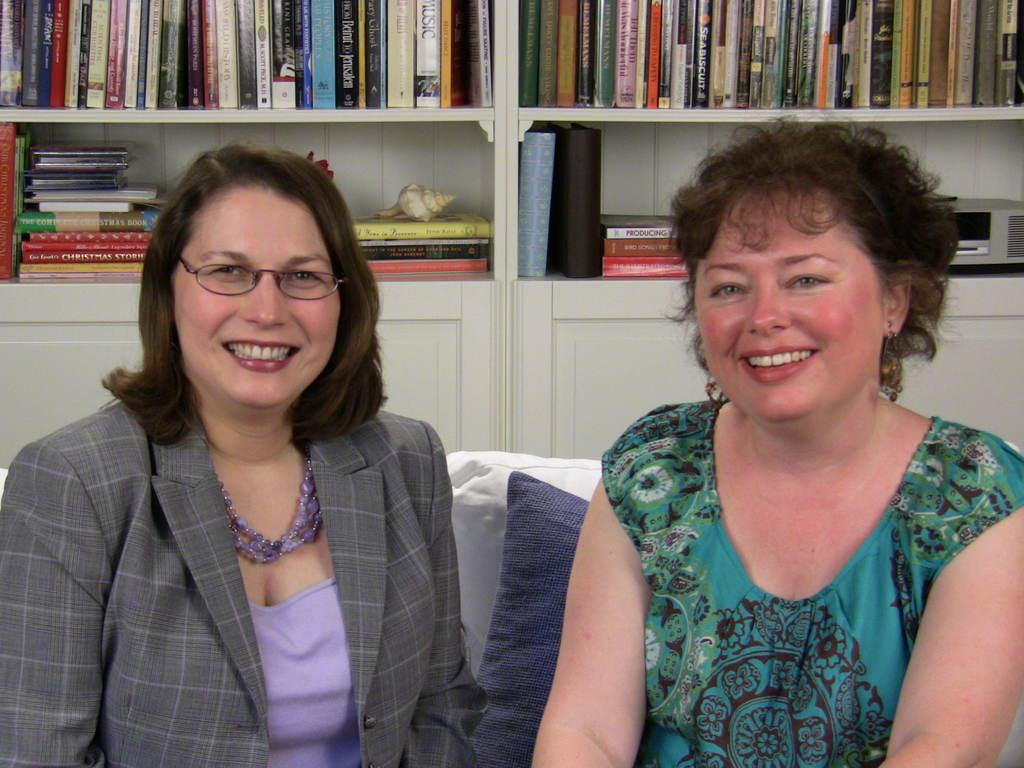How many women are sitting in the image? There are two women sitting in the image. What can be seen in the image that might provide comfort? Cushions are visible in the image. What is located on the backside of the image? There is a group of books, a device, and a shell placed in the shelves on the backside of the image. What type of bridge can be seen in the image? There is no bridge present in the image. 